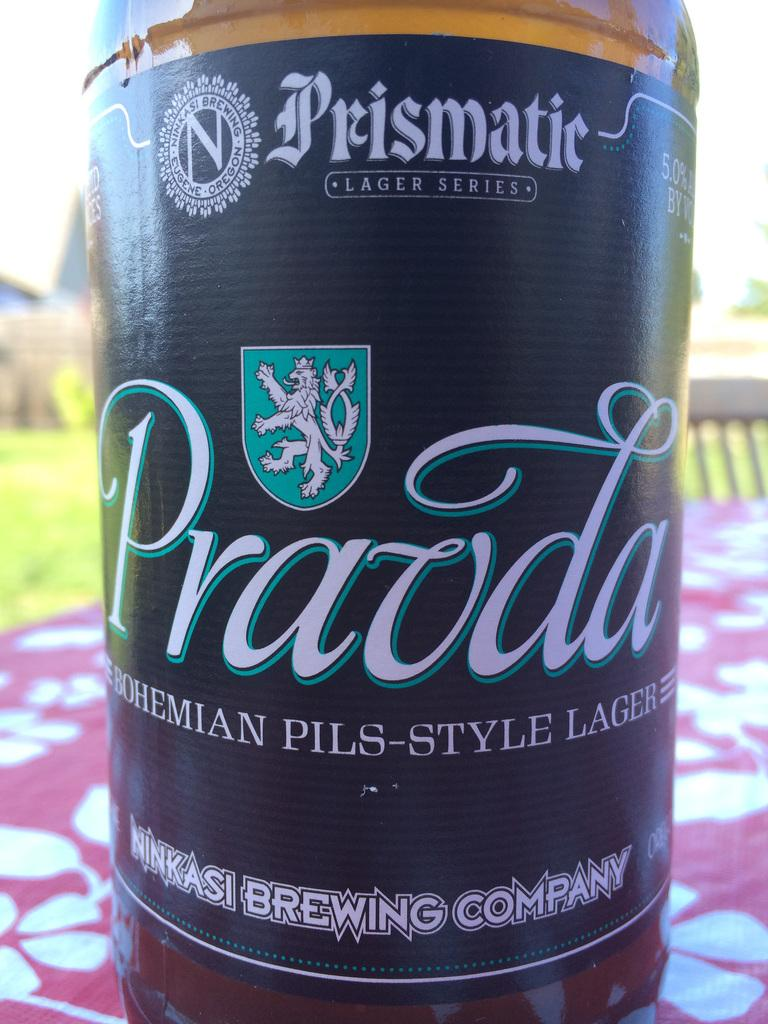<image>
Summarize the visual content of the image. A beer bottle that says Pravda is on an outdoor picnic table. 